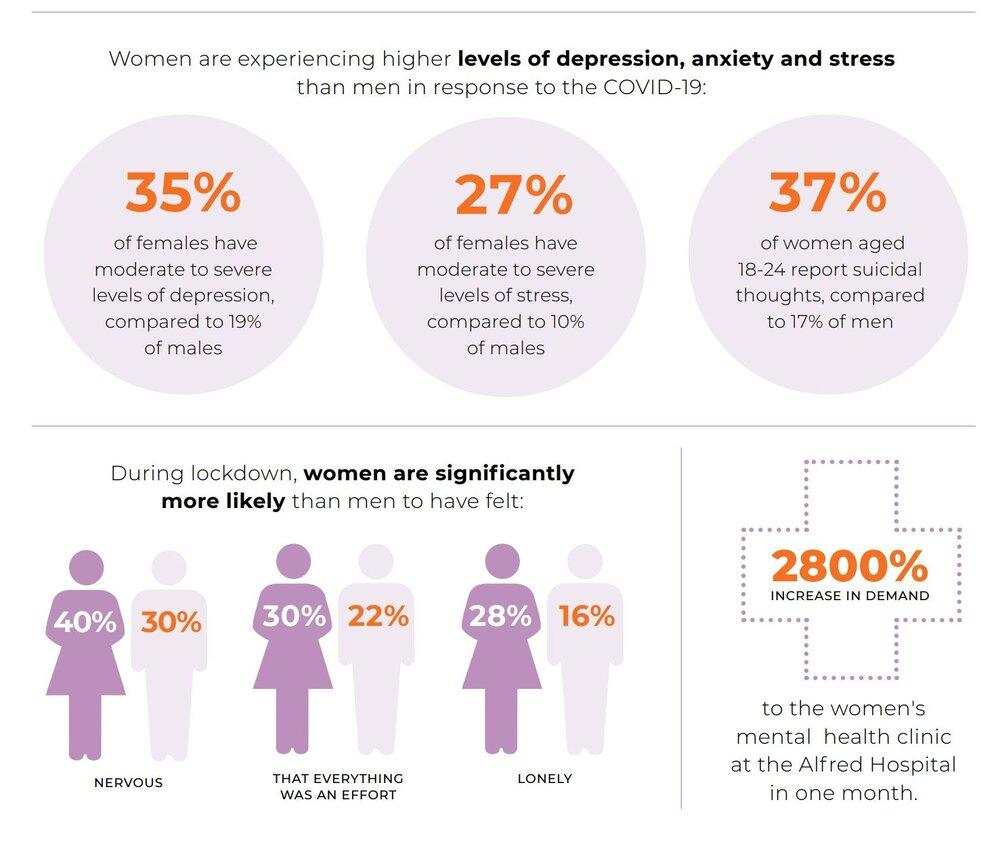Give some essential details in this illustration. During the lockdown period, 19% of men reported experiencing moderate to severe levels of depression, according to the study. During the lockdown period, 37% of women aged 18-24 reported experiencing suicidal thoughts. During the lockdown period, 30% of women reported feeling that everything was an effort, indicating a challenging and stressful experience for many individuals. During the lockdown period, 40% of women reported feeling nervous. During the lockdown period, 10% of men experienced moderate to severe levels of stress. 